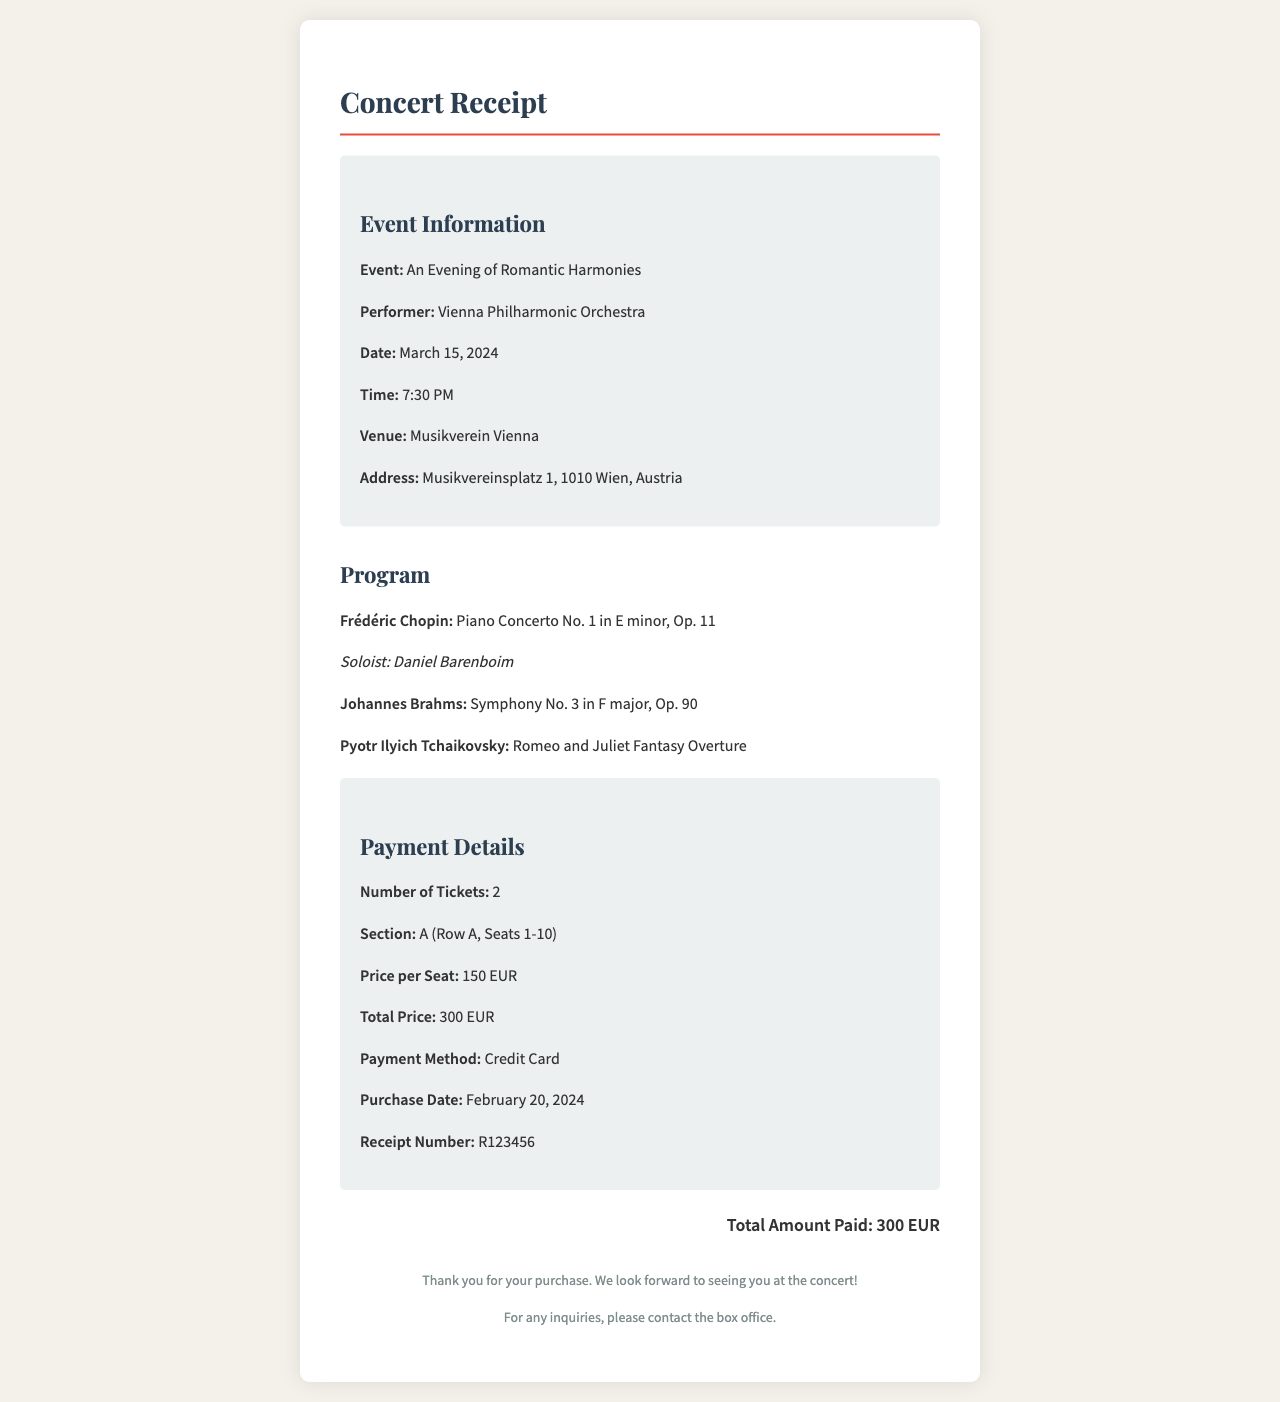What is the name of the event? The document specifies the event as "An Evening of Romantic Harmonies."
Answer: An Evening of Romantic Harmonies Who is the performer for the concert? The document lists the performer as the "Vienna Philharmonic Orchestra."
Answer: Vienna Philharmonic Orchestra What is the total price of the tickets? The total price of the tickets is explicitly stated as "300 EUR."
Answer: 300 EUR When is the concert scheduled? The date provided in the document is "March 15, 2024."
Answer: March 15, 2024 What section are the seats located in? The document indicates that the seats are located in section "A."
Answer: A How many tickets were purchased? The number of tickets stated in the document is "2."
Answer: 2 What is the price per seat? The document shows the price per seat as "150 EUR."
Answer: 150 EUR What was the payment method used? The payment method mentioned in the document is "Credit Card."
Answer: Credit Card What is the receipt number? The document provides the receipt number as "R123456."
Answer: R123456 